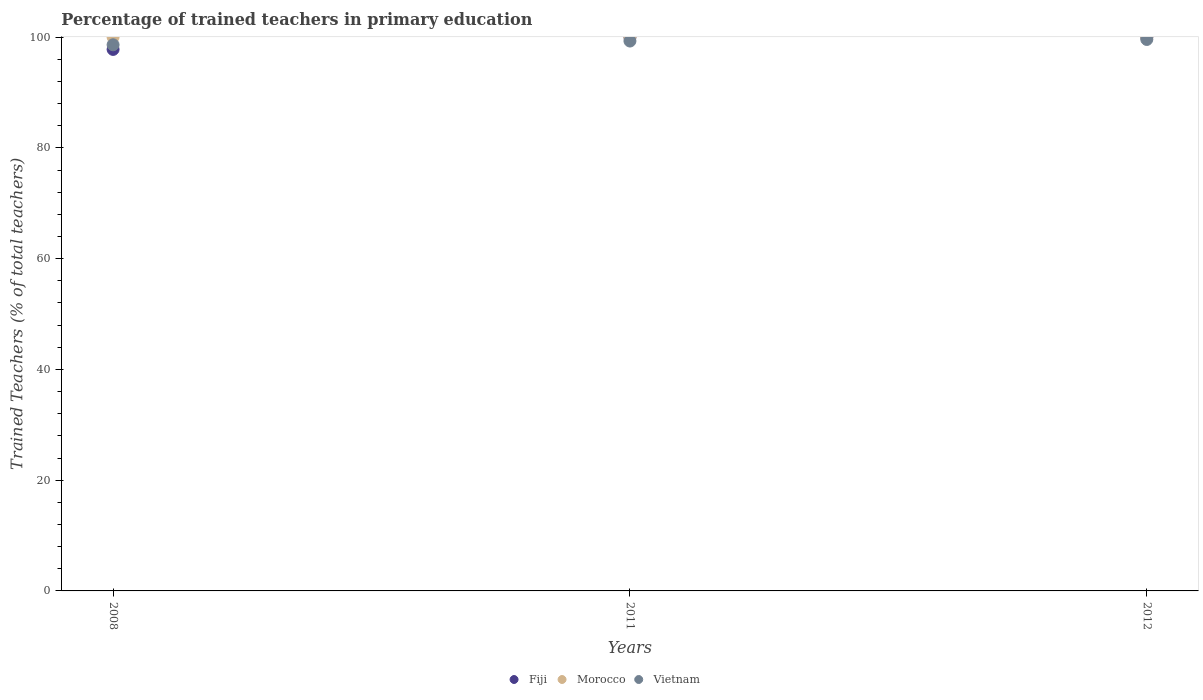Is the number of dotlines equal to the number of legend labels?
Ensure brevity in your answer.  Yes. Across all years, what is the maximum percentage of trained teachers in Vietnam?
Keep it short and to the point. 99.59. What is the total percentage of trained teachers in Fiji in the graph?
Make the answer very short. 297.79. What is the difference between the percentage of trained teachers in Vietnam in 2008 and that in 2012?
Give a very brief answer. -0.96. What is the difference between the percentage of trained teachers in Vietnam in 2008 and the percentage of trained teachers in Morocco in 2012?
Give a very brief answer. -1.37. What is the average percentage of trained teachers in Morocco per year?
Give a very brief answer. 100. In the year 2011, what is the difference between the percentage of trained teachers in Vietnam and percentage of trained teachers in Fiji?
Offer a very short reply. -0.7. What is the ratio of the percentage of trained teachers in Fiji in 2008 to that in 2011?
Ensure brevity in your answer.  0.98. Is the percentage of trained teachers in Vietnam in 2008 less than that in 2012?
Provide a short and direct response. Yes. What is the difference between the highest and the second highest percentage of trained teachers in Vietnam?
Keep it short and to the point. 0.29. What is the difference between the highest and the lowest percentage of trained teachers in Fiji?
Give a very brief answer. 2.21. In how many years, is the percentage of trained teachers in Morocco greater than the average percentage of trained teachers in Morocco taken over all years?
Ensure brevity in your answer.  0. Is the sum of the percentage of trained teachers in Vietnam in 2008 and 2012 greater than the maximum percentage of trained teachers in Morocco across all years?
Make the answer very short. Yes. Is it the case that in every year, the sum of the percentage of trained teachers in Morocco and percentage of trained teachers in Fiji  is greater than the percentage of trained teachers in Vietnam?
Offer a very short reply. Yes. Is the percentage of trained teachers in Vietnam strictly greater than the percentage of trained teachers in Morocco over the years?
Your answer should be very brief. No. Is the percentage of trained teachers in Fiji strictly less than the percentage of trained teachers in Vietnam over the years?
Give a very brief answer. No. How many years are there in the graph?
Keep it short and to the point. 3. Are the values on the major ticks of Y-axis written in scientific E-notation?
Your answer should be very brief. No. Does the graph contain grids?
Make the answer very short. No. Where does the legend appear in the graph?
Keep it short and to the point. Bottom center. How are the legend labels stacked?
Provide a succinct answer. Horizontal. What is the title of the graph?
Make the answer very short. Percentage of trained teachers in primary education. What is the label or title of the Y-axis?
Keep it short and to the point. Trained Teachers (% of total teachers). What is the Trained Teachers (% of total teachers) in Fiji in 2008?
Offer a terse response. 97.79. What is the Trained Teachers (% of total teachers) in Morocco in 2008?
Your response must be concise. 100. What is the Trained Teachers (% of total teachers) in Vietnam in 2008?
Offer a very short reply. 98.63. What is the Trained Teachers (% of total teachers) in Fiji in 2011?
Give a very brief answer. 100. What is the Trained Teachers (% of total teachers) of Vietnam in 2011?
Keep it short and to the point. 99.3. What is the Trained Teachers (% of total teachers) of Morocco in 2012?
Keep it short and to the point. 100. What is the Trained Teachers (% of total teachers) of Vietnam in 2012?
Your answer should be compact. 99.59. Across all years, what is the maximum Trained Teachers (% of total teachers) in Vietnam?
Provide a short and direct response. 99.59. Across all years, what is the minimum Trained Teachers (% of total teachers) of Fiji?
Provide a short and direct response. 97.79. Across all years, what is the minimum Trained Teachers (% of total teachers) of Morocco?
Provide a short and direct response. 100. Across all years, what is the minimum Trained Teachers (% of total teachers) of Vietnam?
Give a very brief answer. 98.63. What is the total Trained Teachers (% of total teachers) of Fiji in the graph?
Ensure brevity in your answer.  297.79. What is the total Trained Teachers (% of total teachers) in Morocco in the graph?
Your answer should be very brief. 300. What is the total Trained Teachers (% of total teachers) in Vietnam in the graph?
Ensure brevity in your answer.  297.52. What is the difference between the Trained Teachers (% of total teachers) in Fiji in 2008 and that in 2011?
Keep it short and to the point. -2.21. What is the difference between the Trained Teachers (% of total teachers) of Morocco in 2008 and that in 2011?
Ensure brevity in your answer.  0. What is the difference between the Trained Teachers (% of total teachers) in Vietnam in 2008 and that in 2011?
Offer a terse response. -0.68. What is the difference between the Trained Teachers (% of total teachers) in Fiji in 2008 and that in 2012?
Provide a short and direct response. -2.21. What is the difference between the Trained Teachers (% of total teachers) of Morocco in 2008 and that in 2012?
Offer a very short reply. 0. What is the difference between the Trained Teachers (% of total teachers) in Vietnam in 2008 and that in 2012?
Keep it short and to the point. -0.96. What is the difference between the Trained Teachers (% of total teachers) of Fiji in 2011 and that in 2012?
Provide a short and direct response. 0. What is the difference between the Trained Teachers (% of total teachers) in Morocco in 2011 and that in 2012?
Your answer should be very brief. 0. What is the difference between the Trained Teachers (% of total teachers) in Vietnam in 2011 and that in 2012?
Offer a very short reply. -0.29. What is the difference between the Trained Teachers (% of total teachers) of Fiji in 2008 and the Trained Teachers (% of total teachers) of Morocco in 2011?
Keep it short and to the point. -2.21. What is the difference between the Trained Teachers (% of total teachers) of Fiji in 2008 and the Trained Teachers (% of total teachers) of Vietnam in 2011?
Give a very brief answer. -1.51. What is the difference between the Trained Teachers (% of total teachers) of Morocco in 2008 and the Trained Teachers (% of total teachers) of Vietnam in 2011?
Keep it short and to the point. 0.7. What is the difference between the Trained Teachers (% of total teachers) of Fiji in 2008 and the Trained Teachers (% of total teachers) of Morocco in 2012?
Your answer should be compact. -2.21. What is the difference between the Trained Teachers (% of total teachers) in Fiji in 2008 and the Trained Teachers (% of total teachers) in Vietnam in 2012?
Your answer should be very brief. -1.8. What is the difference between the Trained Teachers (% of total teachers) of Morocco in 2008 and the Trained Teachers (% of total teachers) of Vietnam in 2012?
Offer a very short reply. 0.41. What is the difference between the Trained Teachers (% of total teachers) of Fiji in 2011 and the Trained Teachers (% of total teachers) of Vietnam in 2012?
Offer a terse response. 0.41. What is the difference between the Trained Teachers (% of total teachers) of Morocco in 2011 and the Trained Teachers (% of total teachers) of Vietnam in 2012?
Ensure brevity in your answer.  0.41. What is the average Trained Teachers (% of total teachers) in Fiji per year?
Your answer should be compact. 99.26. What is the average Trained Teachers (% of total teachers) in Vietnam per year?
Provide a succinct answer. 99.17. In the year 2008, what is the difference between the Trained Teachers (% of total teachers) in Fiji and Trained Teachers (% of total teachers) in Morocco?
Make the answer very short. -2.21. In the year 2008, what is the difference between the Trained Teachers (% of total teachers) of Fiji and Trained Teachers (% of total teachers) of Vietnam?
Offer a very short reply. -0.84. In the year 2008, what is the difference between the Trained Teachers (% of total teachers) in Morocco and Trained Teachers (% of total teachers) in Vietnam?
Make the answer very short. 1.37. In the year 2011, what is the difference between the Trained Teachers (% of total teachers) in Fiji and Trained Teachers (% of total teachers) in Vietnam?
Offer a terse response. 0.7. In the year 2011, what is the difference between the Trained Teachers (% of total teachers) in Morocco and Trained Teachers (% of total teachers) in Vietnam?
Offer a very short reply. 0.7. In the year 2012, what is the difference between the Trained Teachers (% of total teachers) of Fiji and Trained Teachers (% of total teachers) of Vietnam?
Provide a short and direct response. 0.41. In the year 2012, what is the difference between the Trained Teachers (% of total teachers) in Morocco and Trained Teachers (% of total teachers) in Vietnam?
Offer a very short reply. 0.41. What is the ratio of the Trained Teachers (% of total teachers) in Fiji in 2008 to that in 2011?
Offer a very short reply. 0.98. What is the ratio of the Trained Teachers (% of total teachers) of Morocco in 2008 to that in 2011?
Provide a short and direct response. 1. What is the ratio of the Trained Teachers (% of total teachers) of Fiji in 2008 to that in 2012?
Make the answer very short. 0.98. What is the ratio of the Trained Teachers (% of total teachers) in Morocco in 2008 to that in 2012?
Offer a very short reply. 1. What is the ratio of the Trained Teachers (% of total teachers) of Vietnam in 2008 to that in 2012?
Ensure brevity in your answer.  0.99. What is the ratio of the Trained Teachers (% of total teachers) in Morocco in 2011 to that in 2012?
Provide a short and direct response. 1. What is the difference between the highest and the second highest Trained Teachers (% of total teachers) of Fiji?
Offer a very short reply. 0. What is the difference between the highest and the second highest Trained Teachers (% of total teachers) in Morocco?
Provide a short and direct response. 0. What is the difference between the highest and the second highest Trained Teachers (% of total teachers) in Vietnam?
Your response must be concise. 0.29. What is the difference between the highest and the lowest Trained Teachers (% of total teachers) in Fiji?
Keep it short and to the point. 2.21. What is the difference between the highest and the lowest Trained Teachers (% of total teachers) in Morocco?
Ensure brevity in your answer.  0. What is the difference between the highest and the lowest Trained Teachers (% of total teachers) of Vietnam?
Offer a terse response. 0.96. 